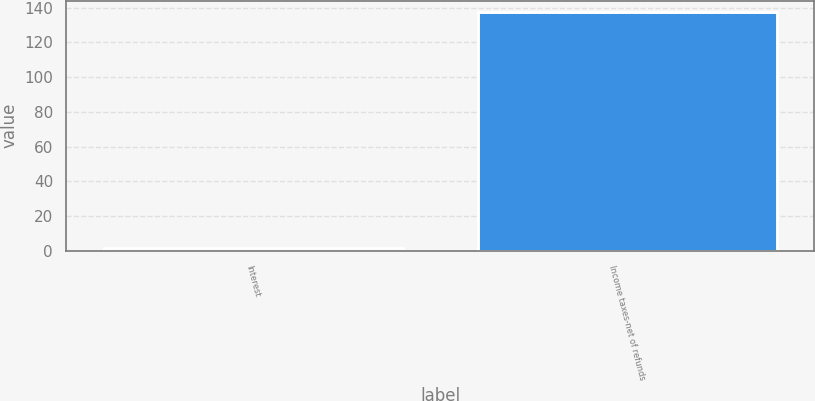<chart> <loc_0><loc_0><loc_500><loc_500><bar_chart><fcel>Interest<fcel>Income taxes-net of refunds<nl><fcel>1.7<fcel>137.2<nl></chart> 